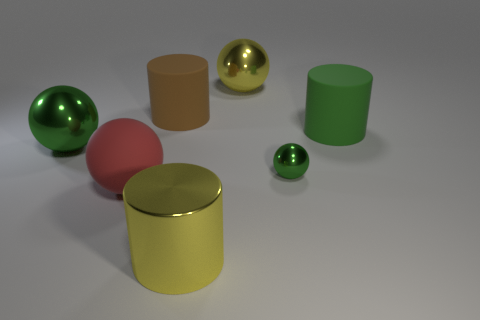Subtract 1 spheres. How many spheres are left? 3 Add 1 large green rubber objects. How many objects exist? 8 Subtract all cylinders. How many objects are left? 4 Subtract 0 yellow cubes. How many objects are left? 7 Subtract all large rubber spheres. Subtract all brown cylinders. How many objects are left? 5 Add 7 large green cylinders. How many large green cylinders are left? 8 Add 1 big brown metallic cubes. How many big brown metallic cubes exist? 1 